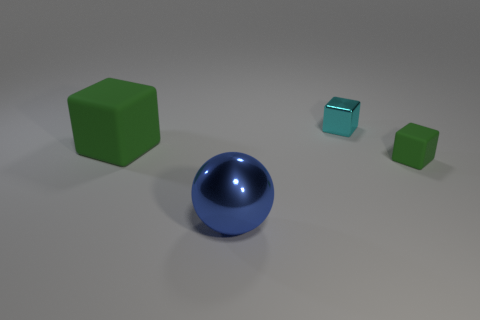Subtract all green rubber blocks. How many blocks are left? 1 Subtract all cyan cylinders. How many green cubes are left? 2 Add 4 small yellow cubes. How many objects exist? 8 Subtract all green cubes. How many cubes are left? 1 Subtract all blocks. How many objects are left? 1 Subtract 0 yellow balls. How many objects are left? 4 Subtract all green spheres. Subtract all brown cubes. How many spheres are left? 1 Subtract all large blue metal things. Subtract all blue things. How many objects are left? 2 Add 1 cubes. How many cubes are left? 4 Add 4 tiny cyan cylinders. How many tiny cyan cylinders exist? 4 